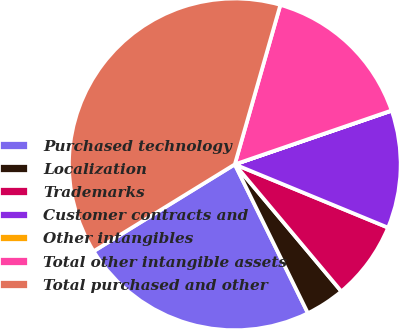Convert chart to OTSL. <chart><loc_0><loc_0><loc_500><loc_500><pie_chart><fcel>Purchased technology<fcel>Localization<fcel>Trademarks<fcel>Customer contracts and<fcel>Other intangibles<fcel>Total other intangible assets<fcel>Total purchased and other<nl><fcel>23.49%<fcel>3.84%<fcel>7.66%<fcel>11.48%<fcel>0.02%<fcel>15.3%<fcel>38.21%<nl></chart> 